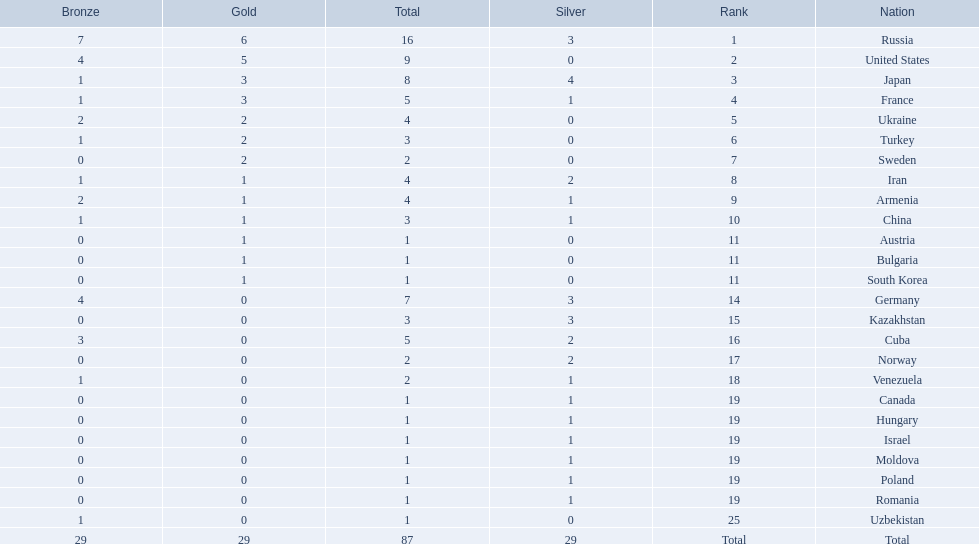What was iran's ranking? 8. What was germany's ranking? 14. Between iran and germany, which was not in the top 10? Germany. 